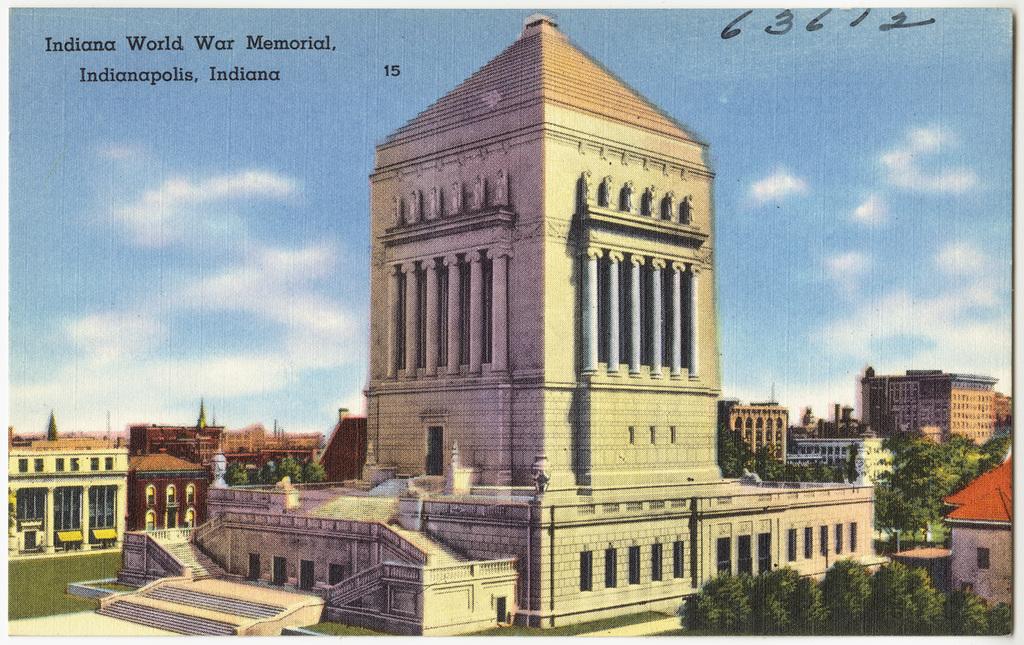What state is this in?
Keep it short and to the point. Indiana. What is the memorial for?
Your response must be concise. Indiana world war memorial. 